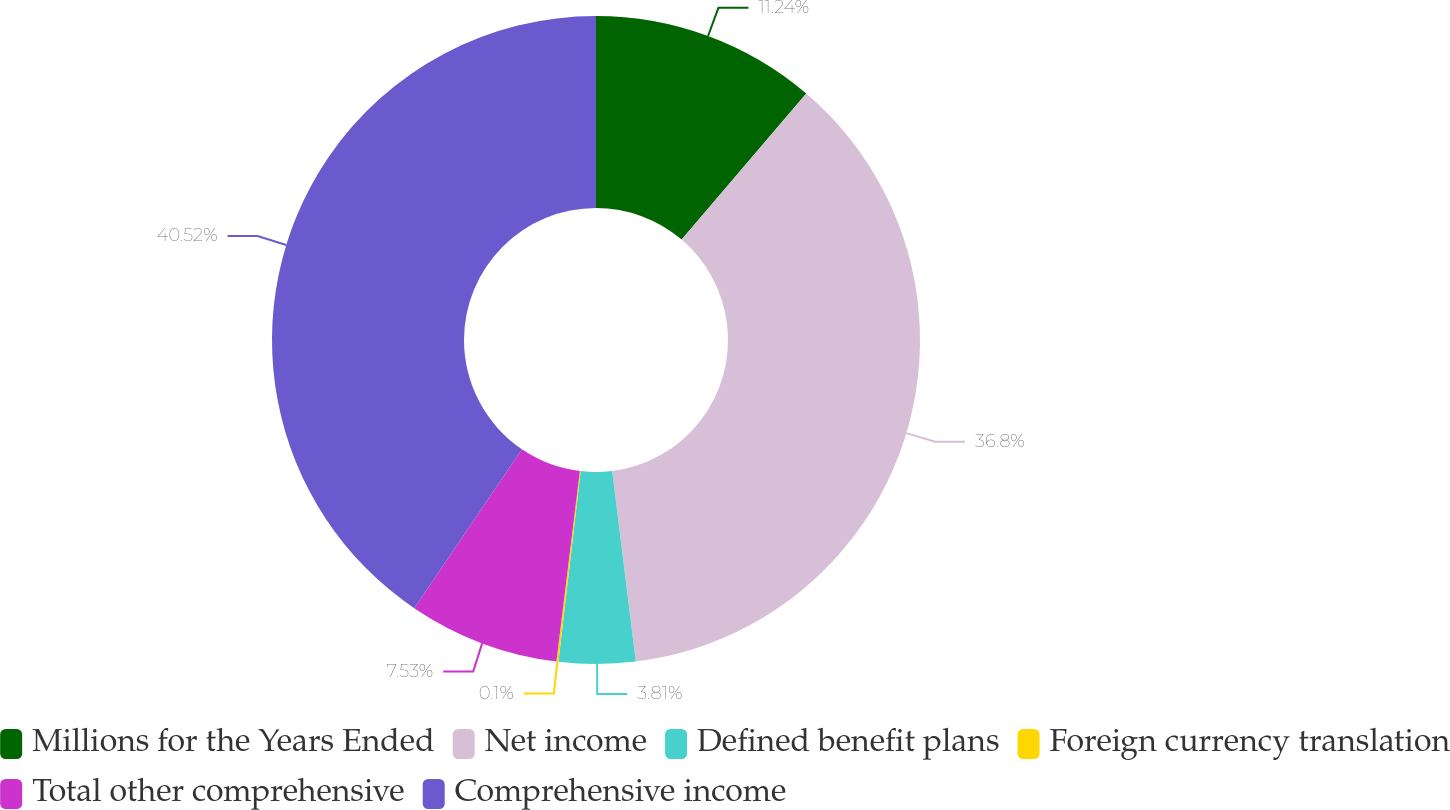Convert chart to OTSL. <chart><loc_0><loc_0><loc_500><loc_500><pie_chart><fcel>Millions for the Years Ended<fcel>Net income<fcel>Defined benefit plans<fcel>Foreign currency translation<fcel>Total other comprehensive<fcel>Comprehensive income<nl><fcel>11.24%<fcel>36.8%<fcel>3.81%<fcel>0.1%<fcel>7.53%<fcel>40.52%<nl></chart> 